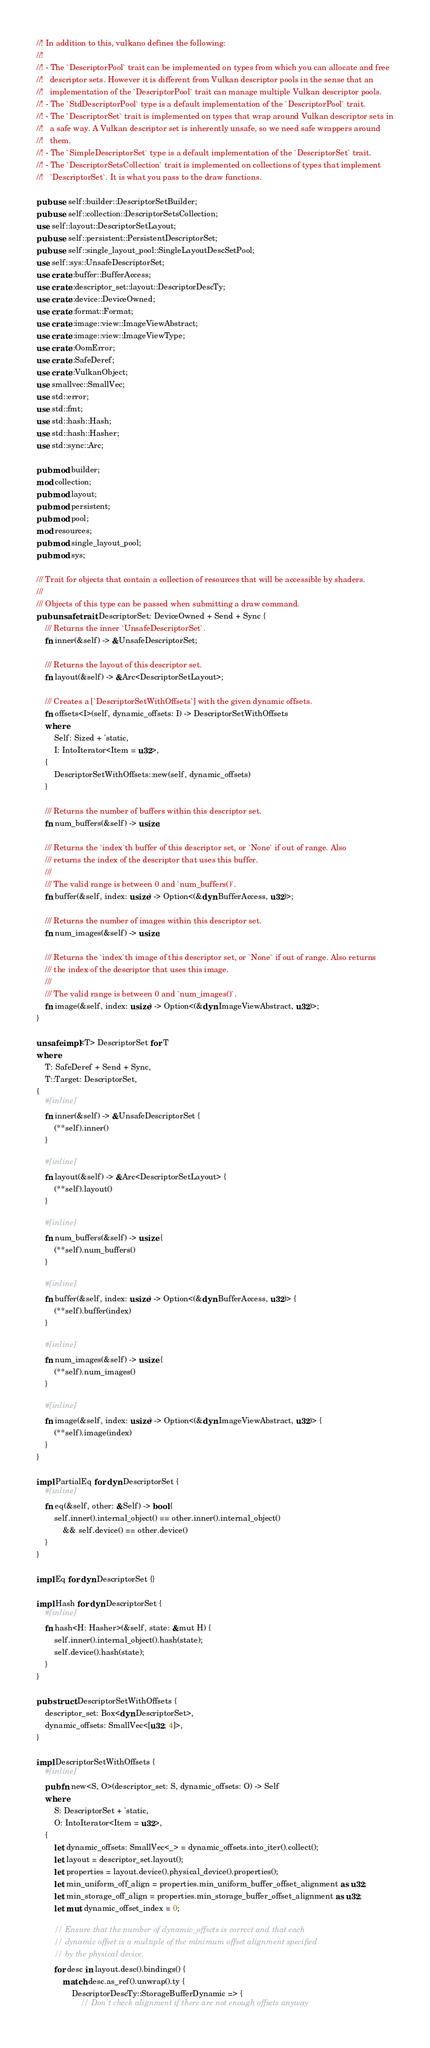Convert code to text. <code><loc_0><loc_0><loc_500><loc_500><_Rust_>//! In addition to this, vulkano defines the following:
//!
//! - The `DescriptorPool` trait can be implemented on types from which you can allocate and free
//!   descriptor sets. However it is different from Vulkan descriptor pools in the sense that an
//!   implementation of the `DescriptorPool` trait can manage multiple Vulkan descriptor pools.
//! - The `StdDescriptorPool` type is a default implementation of the `DescriptorPool` trait.
//! - The `DescriptorSet` trait is implemented on types that wrap around Vulkan descriptor sets in
//!   a safe way. A Vulkan descriptor set is inherently unsafe, so we need safe wrappers around
//!   them.
//! - The `SimpleDescriptorSet` type is a default implementation of the `DescriptorSet` trait.
//! - The `DescriptorSetsCollection` trait is implemented on collections of types that implement
//!   `DescriptorSet`. It is what you pass to the draw functions.

pub use self::builder::DescriptorSetBuilder;
pub use self::collection::DescriptorSetsCollection;
use self::layout::DescriptorSetLayout;
pub use self::persistent::PersistentDescriptorSet;
pub use self::single_layout_pool::SingleLayoutDescSetPool;
use self::sys::UnsafeDescriptorSet;
use crate::buffer::BufferAccess;
use crate::descriptor_set::layout::DescriptorDescTy;
use crate::device::DeviceOwned;
use crate::format::Format;
use crate::image::view::ImageViewAbstract;
use crate::image::view::ImageViewType;
use crate::OomError;
use crate::SafeDeref;
use crate::VulkanObject;
use smallvec::SmallVec;
use std::error;
use std::fmt;
use std::hash::Hash;
use std::hash::Hasher;
use std::sync::Arc;

pub mod builder;
mod collection;
pub mod layout;
pub mod persistent;
pub mod pool;
mod resources;
pub mod single_layout_pool;
pub mod sys;

/// Trait for objects that contain a collection of resources that will be accessible by shaders.
///
/// Objects of this type can be passed when submitting a draw command.
pub unsafe trait DescriptorSet: DeviceOwned + Send + Sync {
    /// Returns the inner `UnsafeDescriptorSet`.
    fn inner(&self) -> &UnsafeDescriptorSet;

    /// Returns the layout of this descriptor set.
    fn layout(&self) -> &Arc<DescriptorSetLayout>;

    /// Creates a [`DescriptorSetWithOffsets`] with the given dynamic offsets.
    fn offsets<I>(self, dynamic_offsets: I) -> DescriptorSetWithOffsets
    where
        Self: Sized + 'static,
        I: IntoIterator<Item = u32>,
    {
        DescriptorSetWithOffsets::new(self, dynamic_offsets)
    }

    /// Returns the number of buffers within this descriptor set.
    fn num_buffers(&self) -> usize;

    /// Returns the `index`th buffer of this descriptor set, or `None` if out of range. Also
    /// returns the index of the descriptor that uses this buffer.
    ///
    /// The valid range is between 0 and `num_buffers()`.
    fn buffer(&self, index: usize) -> Option<(&dyn BufferAccess, u32)>;

    /// Returns the number of images within this descriptor set.
    fn num_images(&self) -> usize;

    /// Returns the `index`th image of this descriptor set, or `None` if out of range. Also returns
    /// the index of the descriptor that uses this image.
    ///
    /// The valid range is between 0 and `num_images()`.
    fn image(&self, index: usize) -> Option<(&dyn ImageViewAbstract, u32)>;
}

unsafe impl<T> DescriptorSet for T
where
    T: SafeDeref + Send + Sync,
    T::Target: DescriptorSet,
{
    #[inline]
    fn inner(&self) -> &UnsafeDescriptorSet {
        (**self).inner()
    }

    #[inline]
    fn layout(&self) -> &Arc<DescriptorSetLayout> {
        (**self).layout()
    }

    #[inline]
    fn num_buffers(&self) -> usize {
        (**self).num_buffers()
    }

    #[inline]
    fn buffer(&self, index: usize) -> Option<(&dyn BufferAccess, u32)> {
        (**self).buffer(index)
    }

    #[inline]
    fn num_images(&self) -> usize {
        (**self).num_images()
    }

    #[inline]
    fn image(&self, index: usize) -> Option<(&dyn ImageViewAbstract, u32)> {
        (**self).image(index)
    }
}

impl PartialEq for dyn DescriptorSet {
    #[inline]
    fn eq(&self, other: &Self) -> bool {
        self.inner().internal_object() == other.inner().internal_object()
            && self.device() == other.device()
    }
}

impl Eq for dyn DescriptorSet {}

impl Hash for dyn DescriptorSet {
    #[inline]
    fn hash<H: Hasher>(&self, state: &mut H) {
        self.inner().internal_object().hash(state);
        self.device().hash(state);
    }
}

pub struct DescriptorSetWithOffsets {
    descriptor_set: Box<dyn DescriptorSet>,
    dynamic_offsets: SmallVec<[u32; 4]>,
}

impl DescriptorSetWithOffsets {
    #[inline]
    pub fn new<S, O>(descriptor_set: S, dynamic_offsets: O) -> Self
    where
        S: DescriptorSet + 'static,
        O: IntoIterator<Item = u32>,
    {
        let dynamic_offsets: SmallVec<_> = dynamic_offsets.into_iter().collect();
        let layout = descriptor_set.layout();
        let properties = layout.device().physical_device().properties();
        let min_uniform_off_align = properties.min_uniform_buffer_offset_alignment as u32;
        let min_storage_off_align = properties.min_storage_buffer_offset_alignment as u32;
        let mut dynamic_offset_index = 0;

        // Ensure that the number of dynamic_offsets is correct and that each
        // dynamic offset is a multiple of the minimum offset alignment specified
        // by the physical device.
        for desc in layout.desc().bindings() {
            match desc.as_ref().unwrap().ty {
                DescriptorDescTy::StorageBufferDynamic => {
                    // Don't check alignment if there are not enough offsets anyway</code> 